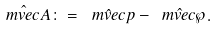<formula> <loc_0><loc_0><loc_500><loc_500>\hat { \ m v e c A } \colon = \hat { \ m v e c p } - \hat { \ m v e c \wp } .</formula> 